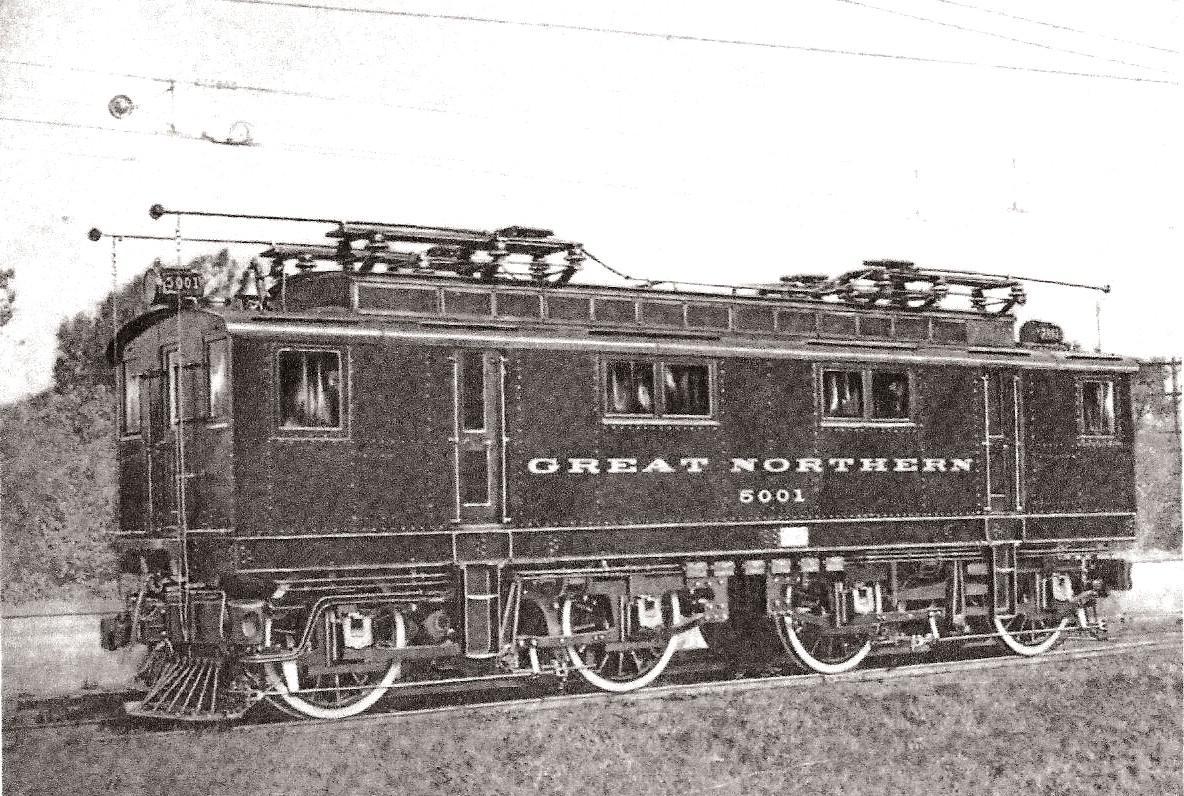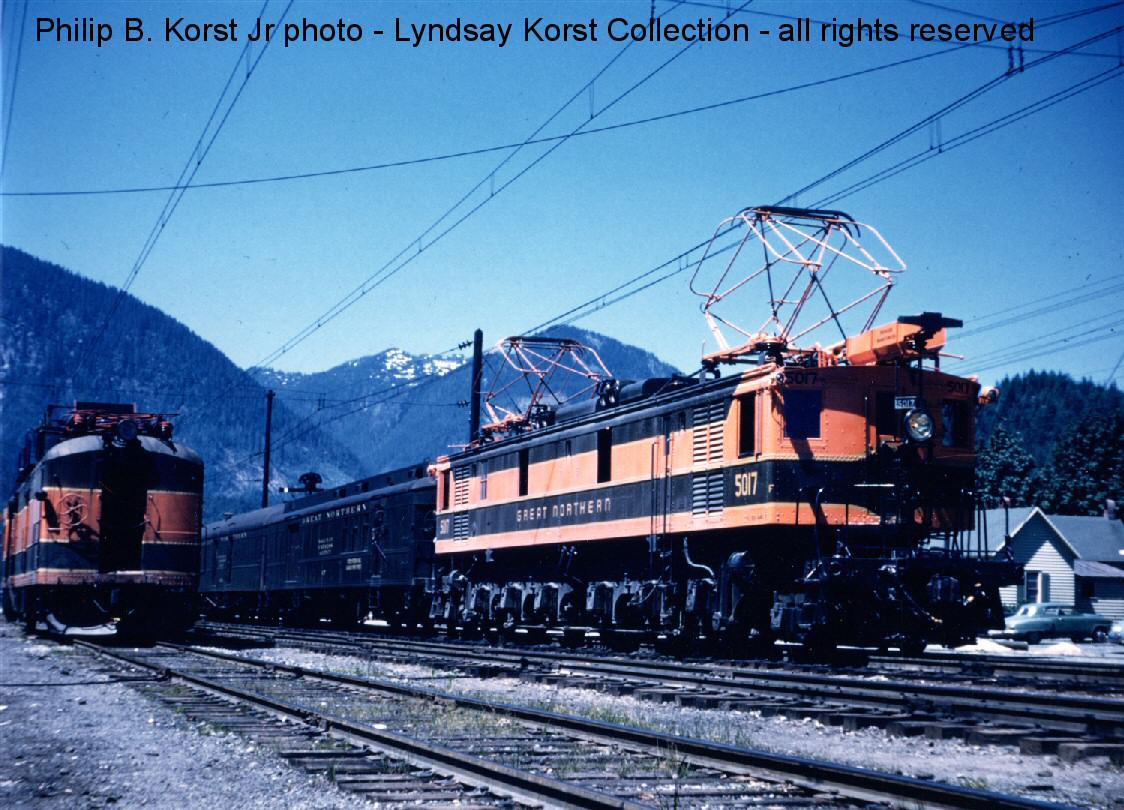The first image is the image on the left, the second image is the image on the right. Analyze the images presented: Is the assertion "One image has a train in front of mountains and is in color." valid? Answer yes or no. Yes. 